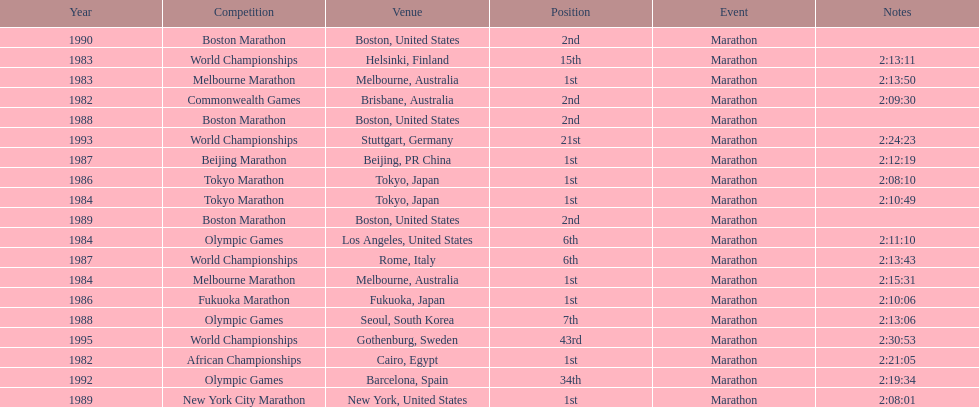What are the total number of times the position of 1st place was earned? 8. 